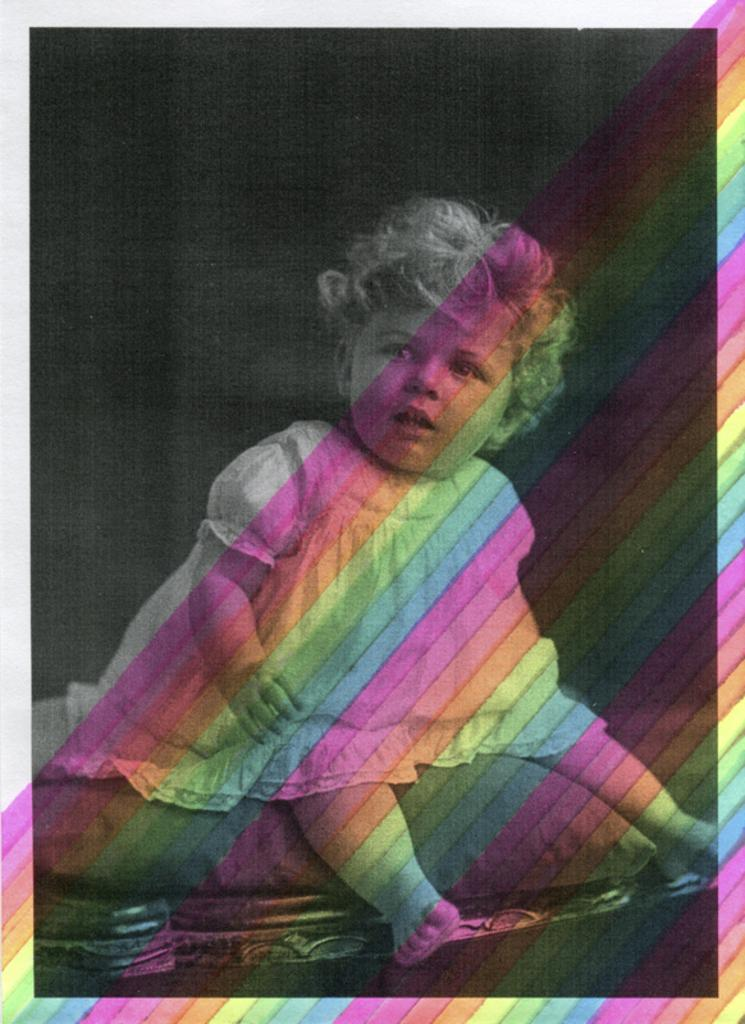What is the main subject of the image? There is a baby in the image. Where is the baby sitting? The baby is sitting on a pillow. What is the pillow placed on? The pillow is placed on a bed. What color is the background of the image? The background of the image is black. What type of lead is the baby holding in the image? There is no lead present in the image; the baby is sitting on a pillow on a bed. Can you see a mailbox in the background of the image? There is no mailbox visible in the image; the background is black. 